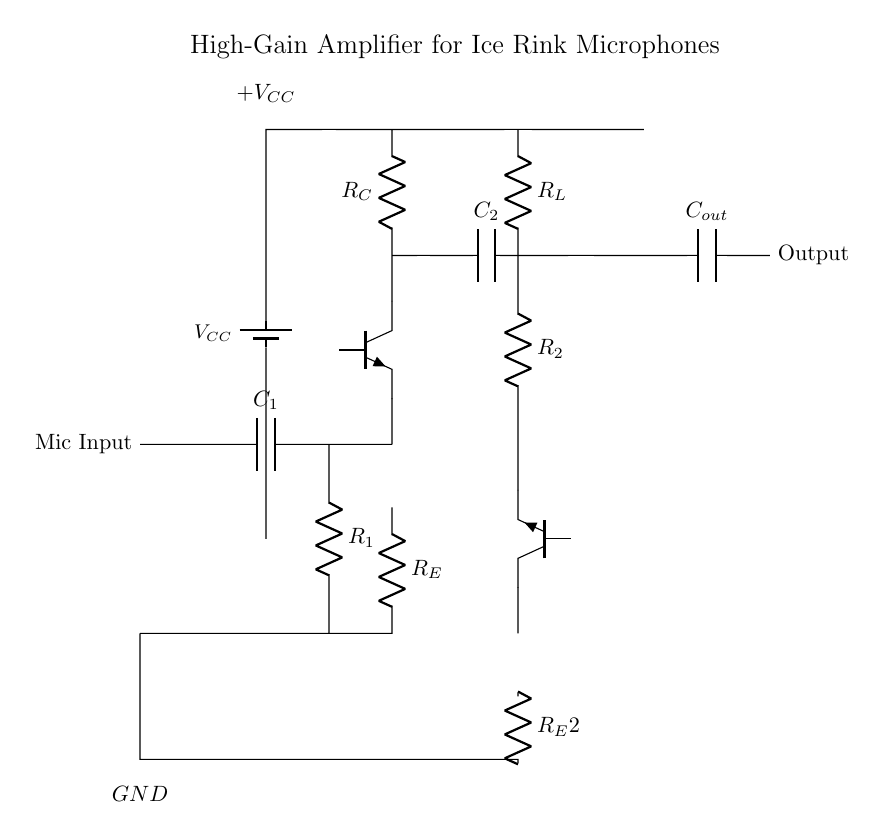What is the type of the first amplifier transistor? The first amplifier transistor is a NPN type, indicated by the symbol Tnpn.
Answer: NPN What is the function of capacitor C1? Capacitor C1 acts as a coupling capacitor that blocks DC while allowing AC signals from the microphone to pass through, thus filtering unwanted DC.
Answer: Coupling What is the purpose of resistor R_L in the circuit? Resistor R_L serves as a load resistor for the second amplifier stage, providing an impedance for the output signal and affecting gain.
Answer: Load resistor What is the configuration of the amplifier shown? The amplifier is in a two-stage configuration, with each stage consisting of a transistor, resistors, and capacitors to sequentially amplify the weak microphone signals.
Answer: Two-stage What is the supply voltage for this amplifier circuit? The circuit uses a supply voltage indicated as VCC, sourced from a battery as shown in the diagram.
Answer: VCC Which component is used to couple the output signal? Capacitor C_out is used for coupling the output signal, allowing AC signals to pass while blocking DC components from reaching the output.
Answer: C_out How many transistors are used in this amplifier circuit? There are two transistors used in this amplifier circuit, which form the two amplification stages for enhancing the input signal.
Answer: Two 